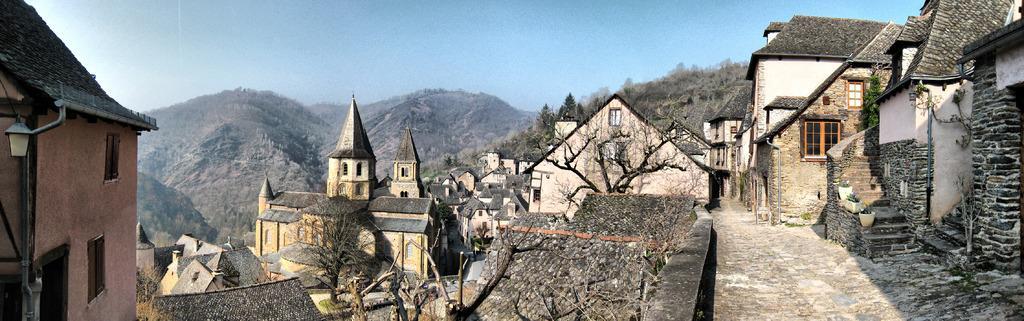Describe this image in one or two sentences. In this picture we can see houses, roof, electric light, pole, grass, trees, floor, stairs, flower pots, pipe, windows, plant, mountains. At the top of the image we can see the sky. 